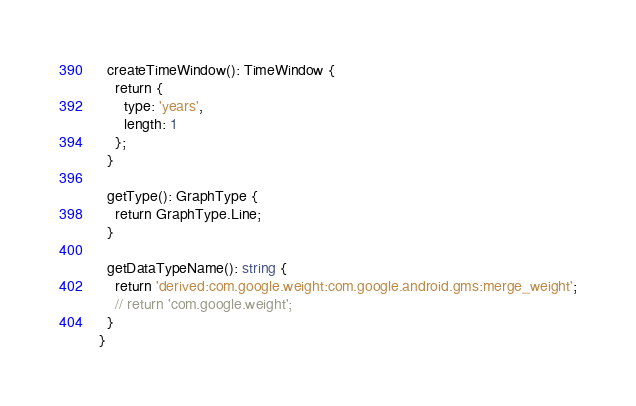Convert code to text. <code><loc_0><loc_0><loc_500><loc_500><_TypeScript_>  createTimeWindow(): TimeWindow {
    return {
      type: 'years',
      length: 1
    };
  }

  getType(): GraphType {
    return GraphType.Line;
  }

  getDataTypeName(): string {
    return 'derived:com.google.weight:com.google.android.gms:merge_weight';
    // return 'com.google.weight';
  }
}
</code> 